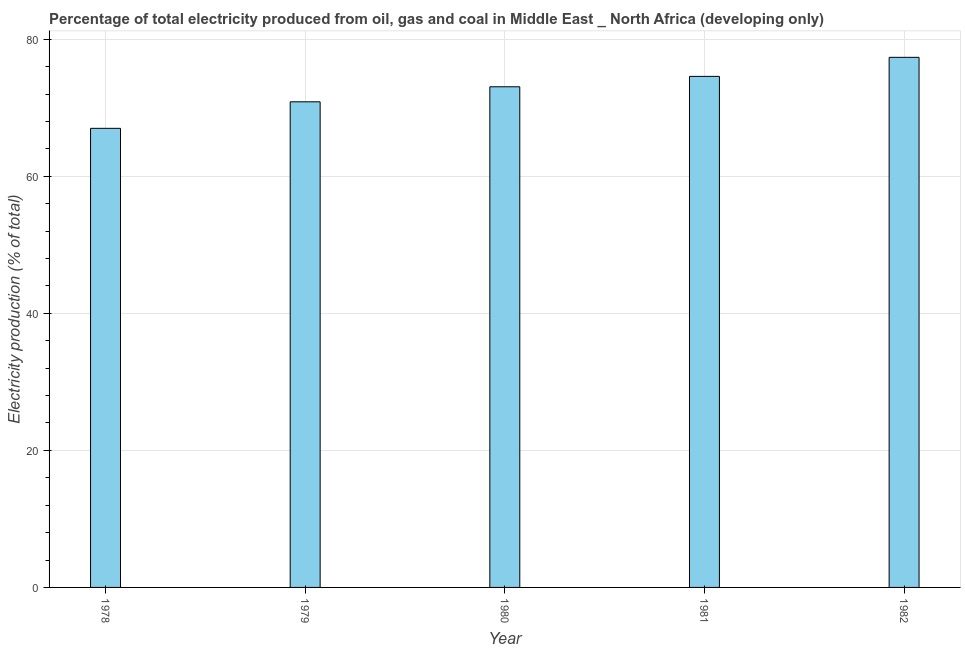What is the title of the graph?
Offer a very short reply. Percentage of total electricity produced from oil, gas and coal in Middle East _ North Africa (developing only). What is the label or title of the X-axis?
Offer a terse response. Year. What is the label or title of the Y-axis?
Offer a terse response. Electricity production (% of total). What is the electricity production in 1981?
Your answer should be compact. 74.58. Across all years, what is the maximum electricity production?
Make the answer very short. 77.36. Across all years, what is the minimum electricity production?
Your answer should be very brief. 67. In which year was the electricity production maximum?
Offer a very short reply. 1982. In which year was the electricity production minimum?
Offer a very short reply. 1978. What is the sum of the electricity production?
Keep it short and to the point. 362.86. What is the difference between the electricity production in 1979 and 1981?
Offer a terse response. -3.71. What is the average electricity production per year?
Ensure brevity in your answer.  72.57. What is the median electricity production?
Your answer should be very brief. 73.06. In how many years, is the electricity production greater than 24 %?
Ensure brevity in your answer.  5. Do a majority of the years between 1982 and 1979 (inclusive) have electricity production greater than 48 %?
Give a very brief answer. Yes. What is the ratio of the electricity production in 1980 to that in 1981?
Provide a succinct answer. 0.98. Is the electricity production in 1981 less than that in 1982?
Keep it short and to the point. Yes. What is the difference between the highest and the second highest electricity production?
Offer a very short reply. 2.78. What is the difference between the highest and the lowest electricity production?
Provide a short and direct response. 10.36. How many bars are there?
Your response must be concise. 5. What is the Electricity production (% of total) of 1978?
Make the answer very short. 67. What is the Electricity production (% of total) of 1979?
Your answer should be very brief. 70.87. What is the Electricity production (% of total) in 1980?
Offer a very short reply. 73.06. What is the Electricity production (% of total) in 1981?
Your answer should be compact. 74.58. What is the Electricity production (% of total) of 1982?
Ensure brevity in your answer.  77.36. What is the difference between the Electricity production (% of total) in 1978 and 1979?
Make the answer very short. -3.87. What is the difference between the Electricity production (% of total) in 1978 and 1980?
Give a very brief answer. -6.07. What is the difference between the Electricity production (% of total) in 1978 and 1981?
Offer a terse response. -7.58. What is the difference between the Electricity production (% of total) in 1978 and 1982?
Your response must be concise. -10.36. What is the difference between the Electricity production (% of total) in 1979 and 1980?
Your response must be concise. -2.19. What is the difference between the Electricity production (% of total) in 1979 and 1981?
Ensure brevity in your answer.  -3.71. What is the difference between the Electricity production (% of total) in 1979 and 1982?
Your response must be concise. -6.49. What is the difference between the Electricity production (% of total) in 1980 and 1981?
Provide a short and direct response. -1.52. What is the difference between the Electricity production (% of total) in 1980 and 1982?
Your response must be concise. -4.3. What is the difference between the Electricity production (% of total) in 1981 and 1982?
Provide a succinct answer. -2.78. What is the ratio of the Electricity production (% of total) in 1978 to that in 1979?
Give a very brief answer. 0.94. What is the ratio of the Electricity production (% of total) in 1978 to that in 1980?
Give a very brief answer. 0.92. What is the ratio of the Electricity production (% of total) in 1978 to that in 1981?
Your answer should be compact. 0.9. What is the ratio of the Electricity production (% of total) in 1978 to that in 1982?
Offer a very short reply. 0.87. What is the ratio of the Electricity production (% of total) in 1979 to that in 1980?
Keep it short and to the point. 0.97. What is the ratio of the Electricity production (% of total) in 1979 to that in 1981?
Keep it short and to the point. 0.95. What is the ratio of the Electricity production (% of total) in 1979 to that in 1982?
Offer a terse response. 0.92. What is the ratio of the Electricity production (% of total) in 1980 to that in 1981?
Give a very brief answer. 0.98. What is the ratio of the Electricity production (% of total) in 1980 to that in 1982?
Provide a short and direct response. 0.94. 